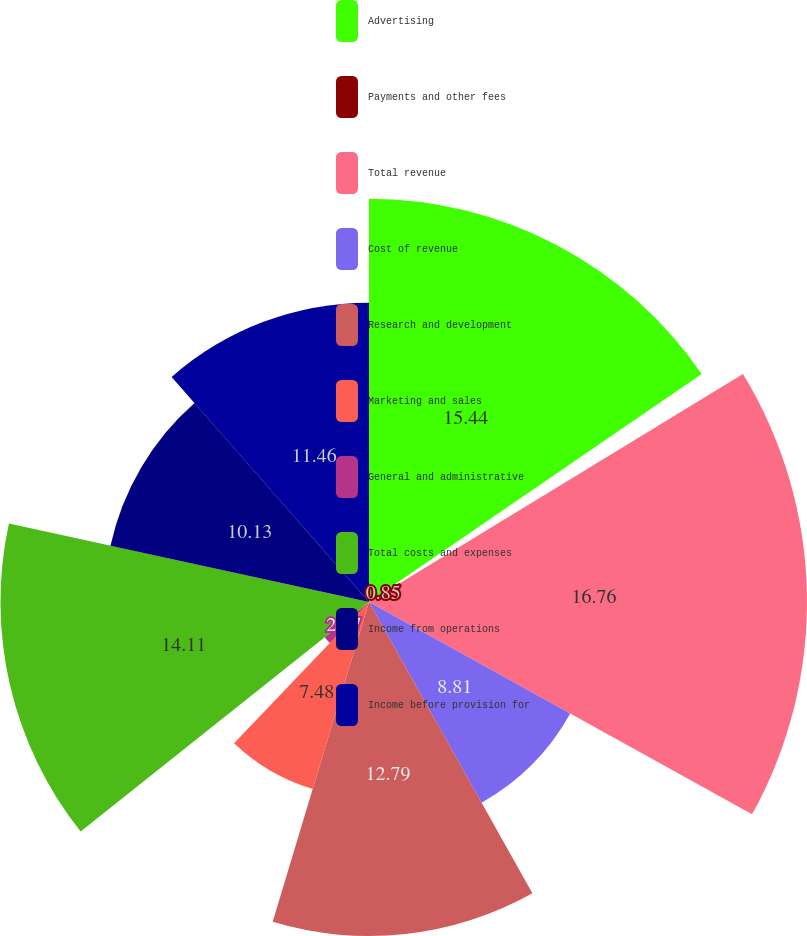Convert chart to OTSL. <chart><loc_0><loc_0><loc_500><loc_500><pie_chart><fcel>Advertising<fcel>Payments and other fees<fcel>Total revenue<fcel>Cost of revenue<fcel>Research and development<fcel>Marketing and sales<fcel>General and administrative<fcel>Total costs and expenses<fcel>Income from operations<fcel>Income before provision for<nl><fcel>15.44%<fcel>0.85%<fcel>16.77%<fcel>8.81%<fcel>12.79%<fcel>7.48%<fcel>2.17%<fcel>14.11%<fcel>10.13%<fcel>11.46%<nl></chart> 